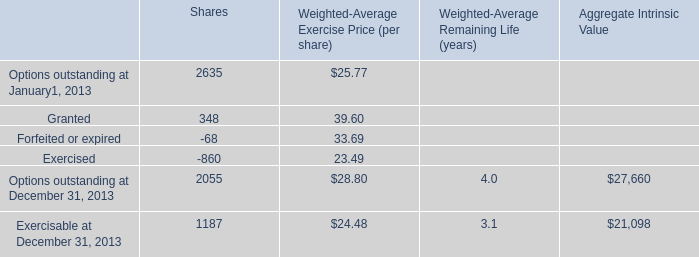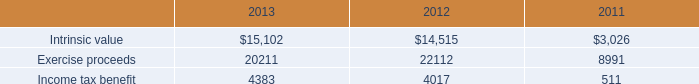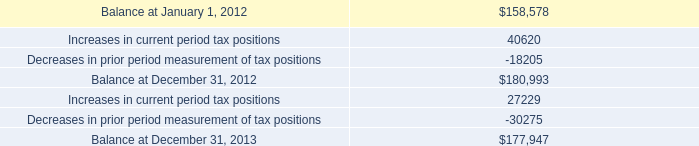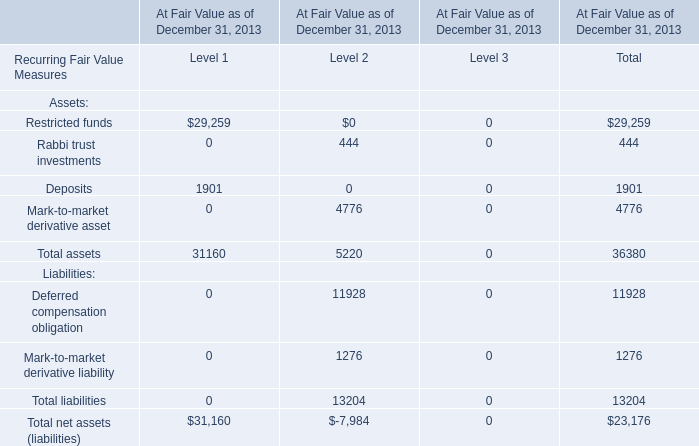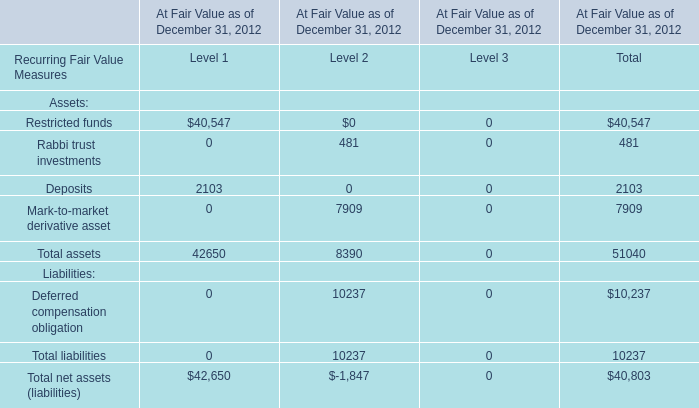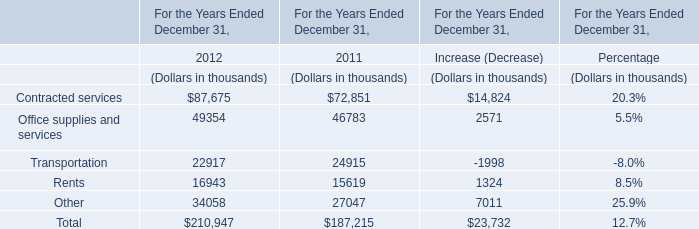What's the total amount of Total assets for Level 2 in 2012? 
Computations: (481 + 7909)
Answer: 8390.0. 